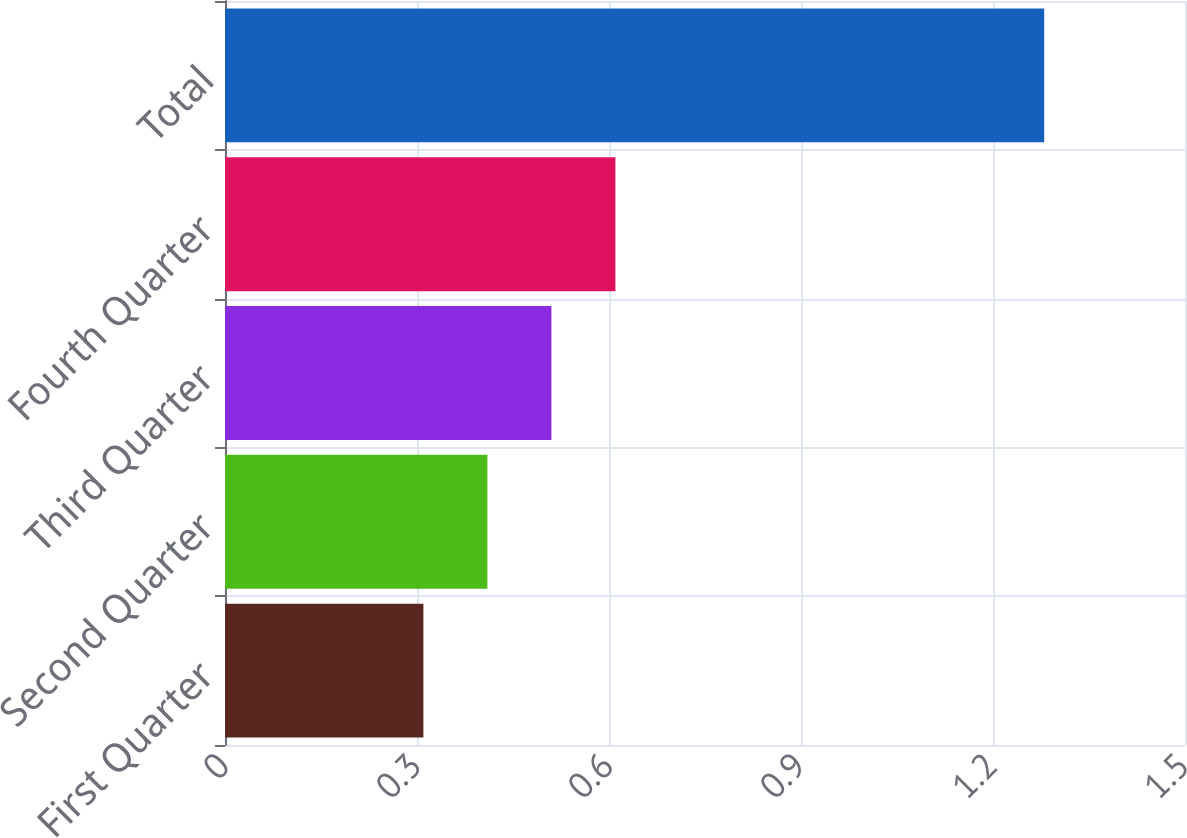<chart> <loc_0><loc_0><loc_500><loc_500><bar_chart><fcel>First Quarter<fcel>Second Quarter<fcel>Third Quarter<fcel>Fourth Quarter<fcel>Total<nl><fcel>0.31<fcel>0.41<fcel>0.51<fcel>0.61<fcel>1.28<nl></chart> 